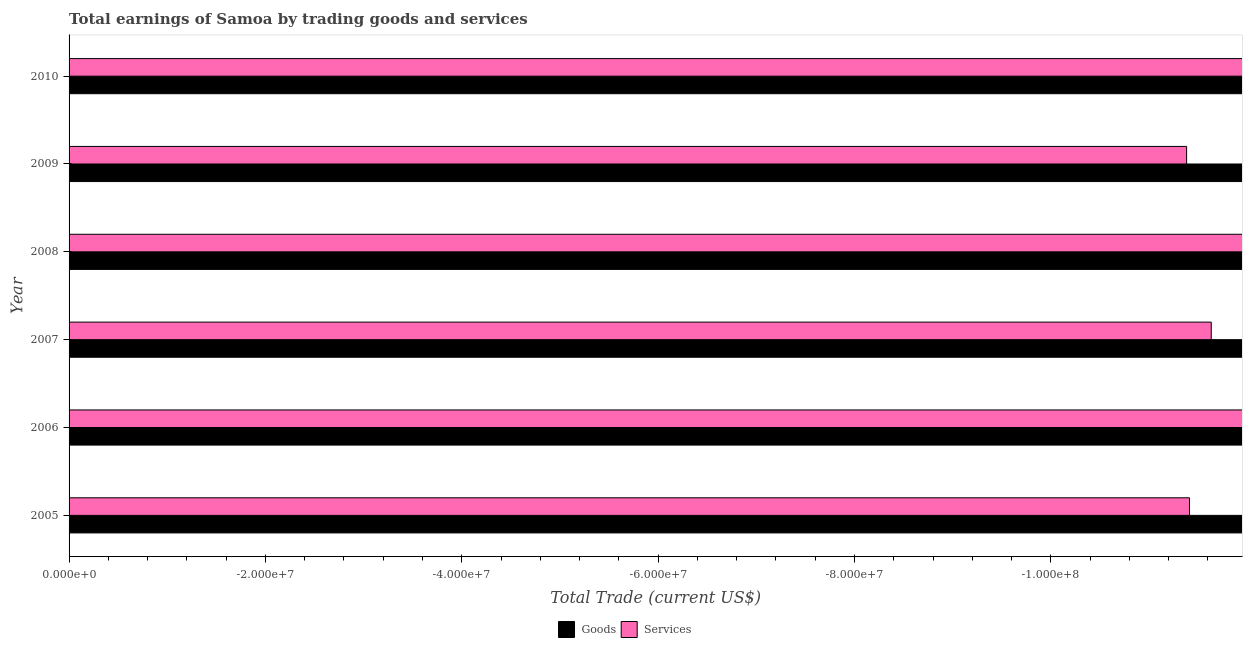How many different coloured bars are there?
Offer a very short reply. 0. Are the number of bars per tick equal to the number of legend labels?
Your answer should be compact. No. Are the number of bars on each tick of the Y-axis equal?
Your answer should be compact. Yes. How many bars are there on the 2nd tick from the top?
Offer a terse response. 0. In how many cases, is the number of bars for a given year not equal to the number of legend labels?
Your response must be concise. 6. Across all years, what is the minimum amount earned by trading services?
Offer a terse response. 0. What is the average amount earned by trading services per year?
Your answer should be compact. 0. In how many years, is the amount earned by trading goods greater than the average amount earned by trading goods taken over all years?
Provide a short and direct response. 0. How many years are there in the graph?
Offer a terse response. 6. Does the graph contain any zero values?
Your answer should be very brief. Yes. Does the graph contain grids?
Ensure brevity in your answer.  No. How many legend labels are there?
Offer a terse response. 2. What is the title of the graph?
Keep it short and to the point. Total earnings of Samoa by trading goods and services. What is the label or title of the X-axis?
Provide a short and direct response. Total Trade (current US$). What is the Total Trade (current US$) in Goods in 2006?
Offer a terse response. 0. What is the Total Trade (current US$) of Services in 2006?
Make the answer very short. 0. What is the Total Trade (current US$) in Goods in 2007?
Give a very brief answer. 0. What is the Total Trade (current US$) of Services in 2008?
Offer a terse response. 0. What is the Total Trade (current US$) in Services in 2010?
Your response must be concise. 0. What is the average Total Trade (current US$) in Services per year?
Ensure brevity in your answer.  0. 